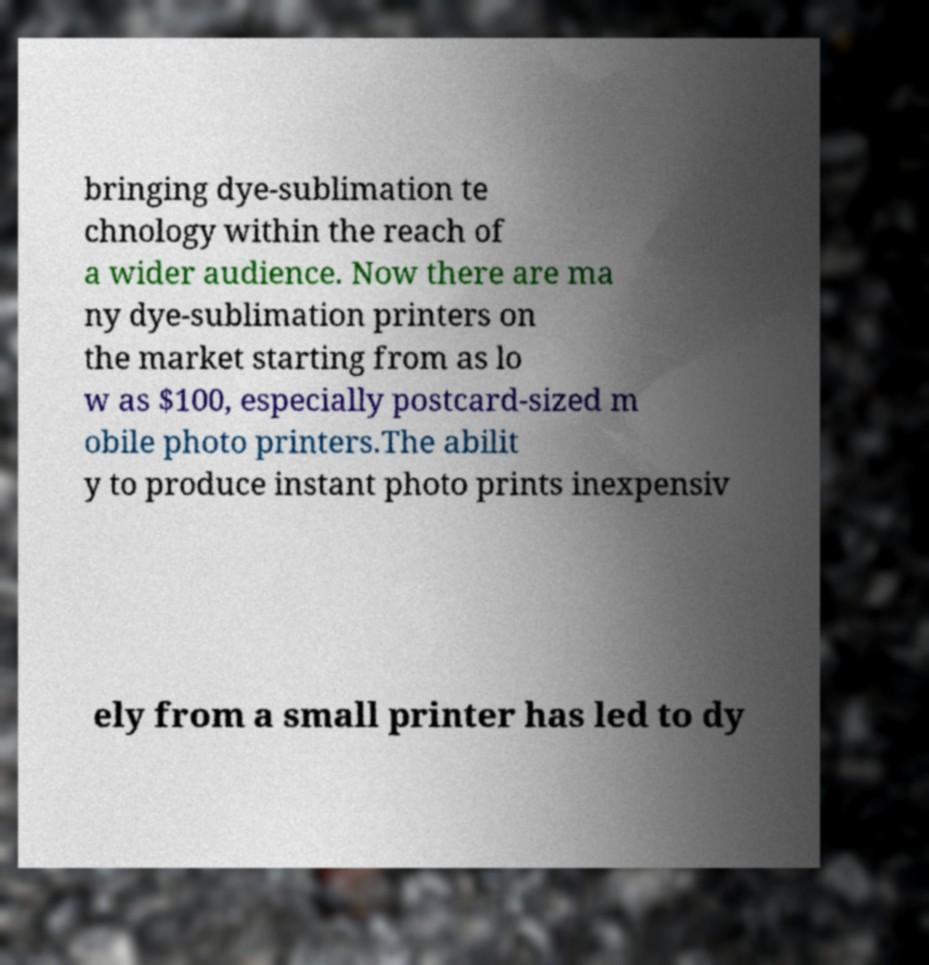Can you accurately transcribe the text from the provided image for me? bringing dye-sublimation te chnology within the reach of a wider audience. Now there are ma ny dye-sublimation printers on the market starting from as lo w as $100, especially postcard-sized m obile photo printers.The abilit y to produce instant photo prints inexpensiv ely from a small printer has led to dy 